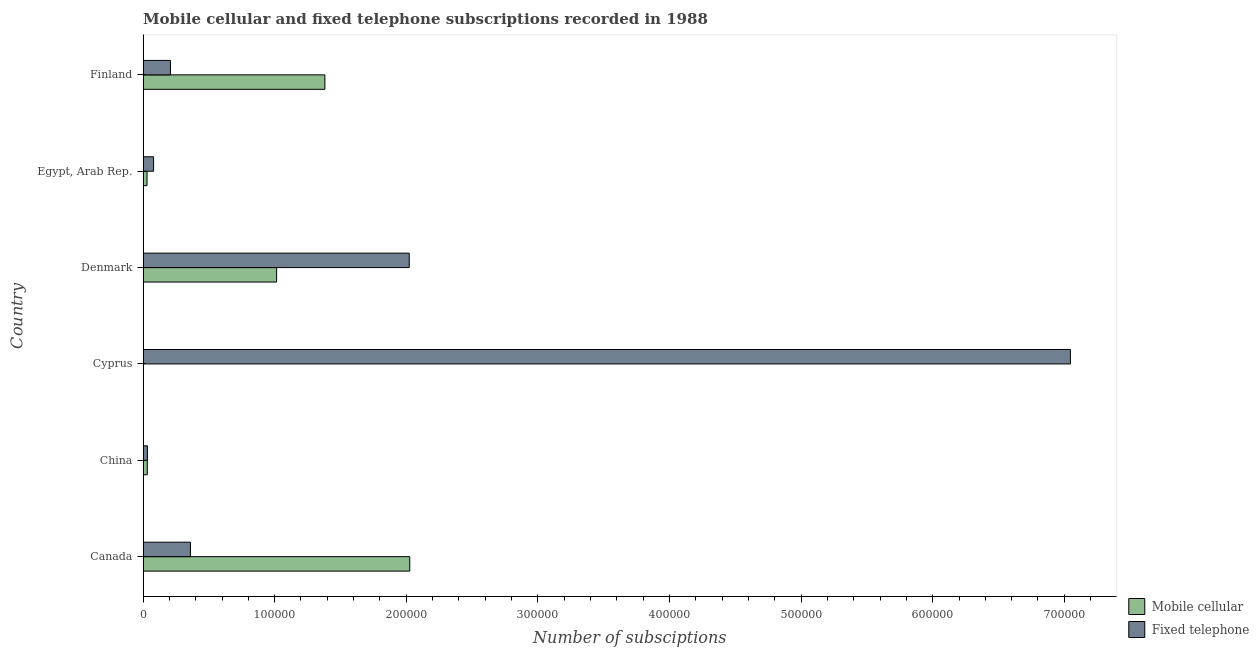How many different coloured bars are there?
Ensure brevity in your answer.  2. How many groups of bars are there?
Give a very brief answer. 6. Are the number of bars per tick equal to the number of legend labels?
Offer a terse response. Yes. Are the number of bars on each tick of the Y-axis equal?
Offer a very short reply. Yes. What is the number of fixed telephone subscriptions in China?
Give a very brief answer. 3319. Across all countries, what is the maximum number of fixed telephone subscriptions?
Ensure brevity in your answer.  7.05e+05. Across all countries, what is the minimum number of fixed telephone subscriptions?
Ensure brevity in your answer.  3319. What is the total number of fixed telephone subscriptions in the graph?
Ensure brevity in your answer.  9.75e+05. What is the difference between the number of fixed telephone subscriptions in Denmark and that in Egypt, Arab Rep.?
Your answer should be compact. 1.94e+05. What is the difference between the number of mobile cellular subscriptions in Canada and the number of fixed telephone subscriptions in Egypt, Arab Rep.?
Your answer should be compact. 1.95e+05. What is the average number of fixed telephone subscriptions per country?
Your answer should be compact. 1.62e+05. What is the difference between the number of mobile cellular subscriptions and number of fixed telephone subscriptions in Canada?
Provide a short and direct response. 1.67e+05. In how many countries, is the number of mobile cellular subscriptions greater than 440000 ?
Offer a very short reply. 0. Is the number of mobile cellular subscriptions in Denmark less than that in Egypt, Arab Rep.?
Your response must be concise. No. What is the difference between the highest and the second highest number of mobile cellular subscriptions?
Your response must be concise. 6.45e+04. What is the difference between the highest and the lowest number of fixed telephone subscriptions?
Your answer should be compact. 7.01e+05. In how many countries, is the number of fixed telephone subscriptions greater than the average number of fixed telephone subscriptions taken over all countries?
Provide a short and direct response. 2. Is the sum of the number of fixed telephone subscriptions in Cyprus and Finland greater than the maximum number of mobile cellular subscriptions across all countries?
Ensure brevity in your answer.  Yes. What does the 2nd bar from the top in Cyprus represents?
Your response must be concise. Mobile cellular. What does the 1st bar from the bottom in China represents?
Provide a short and direct response. Mobile cellular. How many countries are there in the graph?
Give a very brief answer. 6. What is the difference between two consecutive major ticks on the X-axis?
Provide a succinct answer. 1.00e+05. Does the graph contain any zero values?
Keep it short and to the point. No. Does the graph contain grids?
Provide a short and direct response. No. How many legend labels are there?
Provide a succinct answer. 2. How are the legend labels stacked?
Your answer should be compact. Vertical. What is the title of the graph?
Keep it short and to the point. Mobile cellular and fixed telephone subscriptions recorded in 1988. Does "Automatic Teller Machines" appear as one of the legend labels in the graph?
Your answer should be very brief. No. What is the label or title of the X-axis?
Your response must be concise. Number of subsciptions. What is the label or title of the Y-axis?
Ensure brevity in your answer.  Country. What is the Number of subsciptions in Mobile cellular in Canada?
Your answer should be compact. 2.03e+05. What is the Number of subsciptions in Fixed telephone in Canada?
Offer a terse response. 3.60e+04. What is the Number of subsciptions in Mobile cellular in China?
Provide a succinct answer. 3227. What is the Number of subsciptions in Fixed telephone in China?
Offer a terse response. 3319. What is the Number of subsciptions of Mobile cellular in Cyprus?
Your answer should be very brief. 168. What is the Number of subsciptions in Fixed telephone in Cyprus?
Offer a terse response. 7.05e+05. What is the Number of subsciptions of Mobile cellular in Denmark?
Keep it short and to the point. 1.01e+05. What is the Number of subsciptions of Fixed telephone in Denmark?
Provide a succinct answer. 2.02e+05. What is the Number of subsciptions in Mobile cellular in Egypt, Arab Rep.?
Keep it short and to the point. 3021. What is the Number of subsciptions of Fixed telephone in Egypt, Arab Rep.?
Offer a very short reply. 8000. What is the Number of subsciptions in Mobile cellular in Finland?
Offer a terse response. 1.38e+05. What is the Number of subsciptions in Fixed telephone in Finland?
Your response must be concise. 2.08e+04. Across all countries, what is the maximum Number of subsciptions in Mobile cellular?
Provide a short and direct response. 2.03e+05. Across all countries, what is the maximum Number of subsciptions in Fixed telephone?
Your response must be concise. 7.05e+05. Across all countries, what is the minimum Number of subsciptions in Mobile cellular?
Your answer should be very brief. 168. Across all countries, what is the minimum Number of subsciptions in Fixed telephone?
Give a very brief answer. 3319. What is the total Number of subsciptions of Mobile cellular in the graph?
Make the answer very short. 4.49e+05. What is the total Number of subsciptions of Fixed telephone in the graph?
Your response must be concise. 9.75e+05. What is the difference between the Number of subsciptions in Mobile cellular in Canada and that in China?
Your answer should be compact. 1.99e+05. What is the difference between the Number of subsciptions in Fixed telephone in Canada and that in China?
Offer a terse response. 3.27e+04. What is the difference between the Number of subsciptions of Mobile cellular in Canada and that in Cyprus?
Make the answer very short. 2.02e+05. What is the difference between the Number of subsciptions of Fixed telephone in Canada and that in Cyprus?
Give a very brief answer. -6.69e+05. What is the difference between the Number of subsciptions in Mobile cellular in Canada and that in Denmark?
Give a very brief answer. 1.01e+05. What is the difference between the Number of subsciptions in Fixed telephone in Canada and that in Denmark?
Make the answer very short. -1.66e+05. What is the difference between the Number of subsciptions in Mobile cellular in Canada and that in Egypt, Arab Rep.?
Provide a succinct answer. 2.00e+05. What is the difference between the Number of subsciptions in Fixed telephone in Canada and that in Egypt, Arab Rep.?
Your answer should be compact. 2.80e+04. What is the difference between the Number of subsciptions in Mobile cellular in Canada and that in Finland?
Your response must be concise. 6.45e+04. What is the difference between the Number of subsciptions of Fixed telephone in Canada and that in Finland?
Provide a succinct answer. 1.52e+04. What is the difference between the Number of subsciptions of Mobile cellular in China and that in Cyprus?
Ensure brevity in your answer.  3059. What is the difference between the Number of subsciptions in Fixed telephone in China and that in Cyprus?
Make the answer very short. -7.01e+05. What is the difference between the Number of subsciptions of Mobile cellular in China and that in Denmark?
Provide a succinct answer. -9.83e+04. What is the difference between the Number of subsciptions in Fixed telephone in China and that in Denmark?
Your response must be concise. -1.99e+05. What is the difference between the Number of subsciptions of Mobile cellular in China and that in Egypt, Arab Rep.?
Your response must be concise. 206. What is the difference between the Number of subsciptions of Fixed telephone in China and that in Egypt, Arab Rep.?
Ensure brevity in your answer.  -4681. What is the difference between the Number of subsciptions of Mobile cellular in China and that in Finland?
Offer a terse response. -1.35e+05. What is the difference between the Number of subsciptions of Fixed telephone in China and that in Finland?
Keep it short and to the point. -1.75e+04. What is the difference between the Number of subsciptions in Mobile cellular in Cyprus and that in Denmark?
Provide a short and direct response. -1.01e+05. What is the difference between the Number of subsciptions of Fixed telephone in Cyprus and that in Denmark?
Offer a terse response. 5.02e+05. What is the difference between the Number of subsciptions in Mobile cellular in Cyprus and that in Egypt, Arab Rep.?
Your answer should be very brief. -2853. What is the difference between the Number of subsciptions in Fixed telephone in Cyprus and that in Egypt, Arab Rep.?
Your answer should be compact. 6.97e+05. What is the difference between the Number of subsciptions in Mobile cellular in Cyprus and that in Finland?
Your answer should be very brief. -1.38e+05. What is the difference between the Number of subsciptions in Fixed telephone in Cyprus and that in Finland?
Provide a short and direct response. 6.84e+05. What is the difference between the Number of subsciptions in Mobile cellular in Denmark and that in Egypt, Arab Rep.?
Provide a succinct answer. 9.85e+04. What is the difference between the Number of subsciptions in Fixed telephone in Denmark and that in Egypt, Arab Rep.?
Keep it short and to the point. 1.94e+05. What is the difference between the Number of subsciptions in Mobile cellular in Denmark and that in Finland?
Make the answer very short. -3.67e+04. What is the difference between the Number of subsciptions of Fixed telephone in Denmark and that in Finland?
Offer a terse response. 1.81e+05. What is the difference between the Number of subsciptions of Mobile cellular in Egypt, Arab Rep. and that in Finland?
Your answer should be very brief. -1.35e+05. What is the difference between the Number of subsciptions of Fixed telephone in Egypt, Arab Rep. and that in Finland?
Ensure brevity in your answer.  -1.28e+04. What is the difference between the Number of subsciptions in Mobile cellular in Canada and the Number of subsciptions in Fixed telephone in China?
Make the answer very short. 1.99e+05. What is the difference between the Number of subsciptions in Mobile cellular in Canada and the Number of subsciptions in Fixed telephone in Cyprus?
Provide a short and direct response. -5.02e+05. What is the difference between the Number of subsciptions in Mobile cellular in Canada and the Number of subsciptions in Fixed telephone in Denmark?
Ensure brevity in your answer.  389. What is the difference between the Number of subsciptions in Mobile cellular in Canada and the Number of subsciptions in Fixed telephone in Egypt, Arab Rep.?
Make the answer very short. 1.95e+05. What is the difference between the Number of subsciptions of Mobile cellular in Canada and the Number of subsciptions of Fixed telephone in Finland?
Your response must be concise. 1.82e+05. What is the difference between the Number of subsciptions in Mobile cellular in China and the Number of subsciptions in Fixed telephone in Cyprus?
Ensure brevity in your answer.  -7.01e+05. What is the difference between the Number of subsciptions of Mobile cellular in China and the Number of subsciptions of Fixed telephone in Denmark?
Ensure brevity in your answer.  -1.99e+05. What is the difference between the Number of subsciptions of Mobile cellular in China and the Number of subsciptions of Fixed telephone in Egypt, Arab Rep.?
Ensure brevity in your answer.  -4773. What is the difference between the Number of subsciptions in Mobile cellular in China and the Number of subsciptions in Fixed telephone in Finland?
Offer a very short reply. -1.76e+04. What is the difference between the Number of subsciptions in Mobile cellular in Cyprus and the Number of subsciptions in Fixed telephone in Denmark?
Your answer should be very brief. -2.02e+05. What is the difference between the Number of subsciptions in Mobile cellular in Cyprus and the Number of subsciptions in Fixed telephone in Egypt, Arab Rep.?
Make the answer very short. -7832. What is the difference between the Number of subsciptions of Mobile cellular in Cyprus and the Number of subsciptions of Fixed telephone in Finland?
Your response must be concise. -2.06e+04. What is the difference between the Number of subsciptions of Mobile cellular in Denmark and the Number of subsciptions of Fixed telephone in Egypt, Arab Rep.?
Offer a terse response. 9.35e+04. What is the difference between the Number of subsciptions in Mobile cellular in Denmark and the Number of subsciptions in Fixed telephone in Finland?
Your answer should be very brief. 8.07e+04. What is the difference between the Number of subsciptions in Mobile cellular in Egypt, Arab Rep. and the Number of subsciptions in Fixed telephone in Finland?
Offer a terse response. -1.78e+04. What is the average Number of subsciptions of Mobile cellular per country?
Offer a very short reply. 7.48e+04. What is the average Number of subsciptions in Fixed telephone per country?
Your response must be concise. 1.62e+05. What is the difference between the Number of subsciptions of Mobile cellular and Number of subsciptions of Fixed telephone in Canada?
Make the answer very short. 1.67e+05. What is the difference between the Number of subsciptions of Mobile cellular and Number of subsciptions of Fixed telephone in China?
Your answer should be very brief. -92. What is the difference between the Number of subsciptions of Mobile cellular and Number of subsciptions of Fixed telephone in Cyprus?
Give a very brief answer. -7.04e+05. What is the difference between the Number of subsciptions of Mobile cellular and Number of subsciptions of Fixed telephone in Denmark?
Offer a terse response. -1.01e+05. What is the difference between the Number of subsciptions in Mobile cellular and Number of subsciptions in Fixed telephone in Egypt, Arab Rep.?
Ensure brevity in your answer.  -4979. What is the difference between the Number of subsciptions of Mobile cellular and Number of subsciptions of Fixed telephone in Finland?
Your answer should be compact. 1.17e+05. What is the ratio of the Number of subsciptions of Mobile cellular in Canada to that in China?
Keep it short and to the point. 62.79. What is the ratio of the Number of subsciptions of Fixed telephone in Canada to that in China?
Give a very brief answer. 10.85. What is the ratio of the Number of subsciptions of Mobile cellular in Canada to that in Cyprus?
Make the answer very short. 1206.15. What is the ratio of the Number of subsciptions of Fixed telephone in Canada to that in Cyprus?
Your answer should be very brief. 0.05. What is the ratio of the Number of subsciptions of Mobile cellular in Canada to that in Denmark?
Provide a succinct answer. 2. What is the ratio of the Number of subsciptions of Fixed telephone in Canada to that in Denmark?
Provide a succinct answer. 0.18. What is the ratio of the Number of subsciptions in Mobile cellular in Canada to that in Egypt, Arab Rep.?
Keep it short and to the point. 67.07. What is the ratio of the Number of subsciptions of Fixed telephone in Canada to that in Egypt, Arab Rep.?
Give a very brief answer. 4.5. What is the ratio of the Number of subsciptions in Mobile cellular in Canada to that in Finland?
Make the answer very short. 1.47. What is the ratio of the Number of subsciptions in Fixed telephone in Canada to that in Finland?
Provide a succinct answer. 1.73. What is the ratio of the Number of subsciptions in Mobile cellular in China to that in Cyprus?
Ensure brevity in your answer.  19.21. What is the ratio of the Number of subsciptions of Fixed telephone in China to that in Cyprus?
Give a very brief answer. 0. What is the ratio of the Number of subsciptions in Mobile cellular in China to that in Denmark?
Your response must be concise. 0.03. What is the ratio of the Number of subsciptions of Fixed telephone in China to that in Denmark?
Provide a succinct answer. 0.02. What is the ratio of the Number of subsciptions of Mobile cellular in China to that in Egypt, Arab Rep.?
Offer a very short reply. 1.07. What is the ratio of the Number of subsciptions of Fixed telephone in China to that in Egypt, Arab Rep.?
Provide a succinct answer. 0.41. What is the ratio of the Number of subsciptions of Mobile cellular in China to that in Finland?
Your answer should be compact. 0.02. What is the ratio of the Number of subsciptions in Fixed telephone in China to that in Finland?
Provide a short and direct response. 0.16. What is the ratio of the Number of subsciptions in Mobile cellular in Cyprus to that in Denmark?
Your answer should be compact. 0. What is the ratio of the Number of subsciptions of Fixed telephone in Cyprus to that in Denmark?
Your response must be concise. 3.48. What is the ratio of the Number of subsciptions of Mobile cellular in Cyprus to that in Egypt, Arab Rep.?
Make the answer very short. 0.06. What is the ratio of the Number of subsciptions of Fixed telephone in Cyprus to that in Egypt, Arab Rep.?
Provide a succinct answer. 88.08. What is the ratio of the Number of subsciptions in Mobile cellular in Cyprus to that in Finland?
Your answer should be very brief. 0. What is the ratio of the Number of subsciptions of Fixed telephone in Cyprus to that in Finland?
Ensure brevity in your answer.  33.85. What is the ratio of the Number of subsciptions in Mobile cellular in Denmark to that in Egypt, Arab Rep.?
Provide a short and direct response. 33.59. What is the ratio of the Number of subsciptions in Fixed telephone in Denmark to that in Egypt, Arab Rep.?
Your answer should be very brief. 25.28. What is the ratio of the Number of subsciptions of Mobile cellular in Denmark to that in Finland?
Give a very brief answer. 0.73. What is the ratio of the Number of subsciptions of Fixed telephone in Denmark to that in Finland?
Your answer should be very brief. 9.72. What is the ratio of the Number of subsciptions of Mobile cellular in Egypt, Arab Rep. to that in Finland?
Ensure brevity in your answer.  0.02. What is the ratio of the Number of subsciptions in Fixed telephone in Egypt, Arab Rep. to that in Finland?
Keep it short and to the point. 0.38. What is the difference between the highest and the second highest Number of subsciptions in Mobile cellular?
Your answer should be very brief. 6.45e+04. What is the difference between the highest and the second highest Number of subsciptions in Fixed telephone?
Provide a short and direct response. 5.02e+05. What is the difference between the highest and the lowest Number of subsciptions of Mobile cellular?
Offer a very short reply. 2.02e+05. What is the difference between the highest and the lowest Number of subsciptions of Fixed telephone?
Provide a short and direct response. 7.01e+05. 